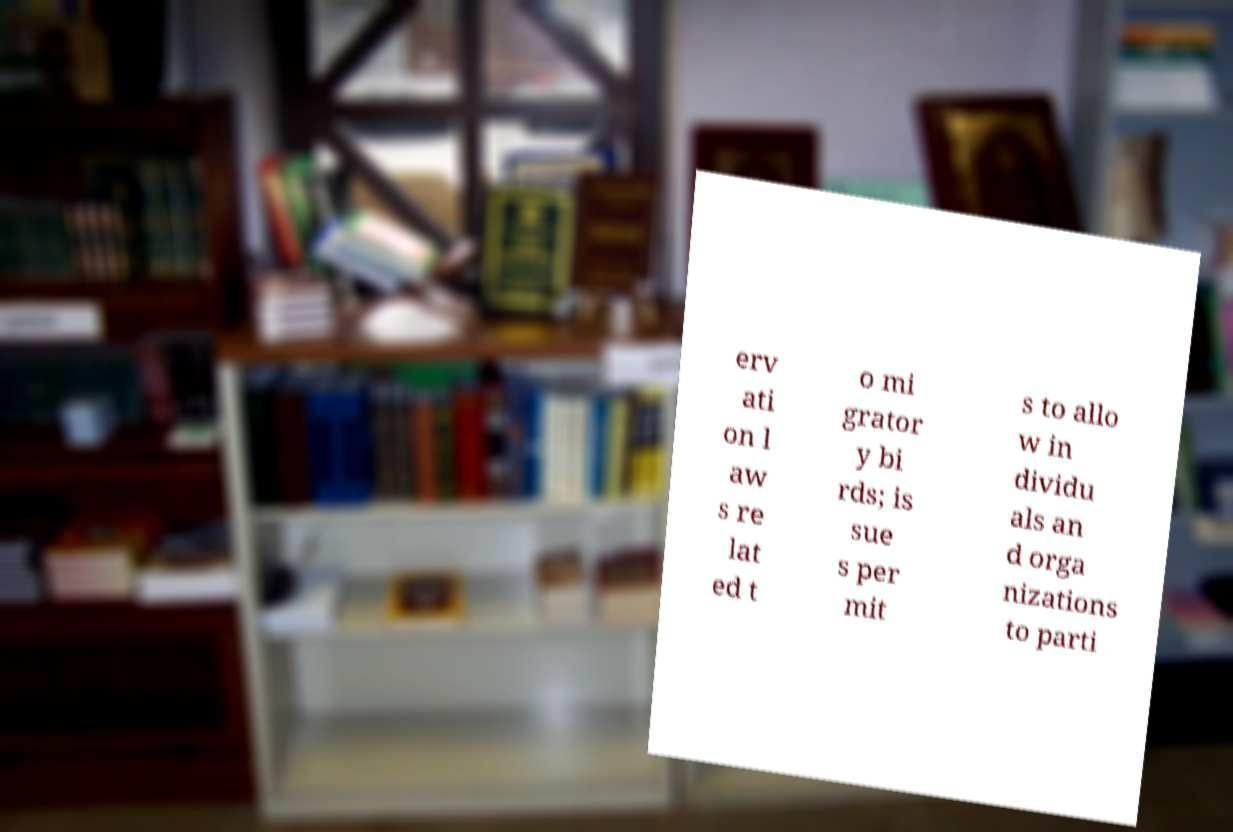Can you accurately transcribe the text from the provided image for me? erv ati on l aw s re lat ed t o mi grator y bi rds; is sue s per mit s to allo w in dividu als an d orga nizations to parti 